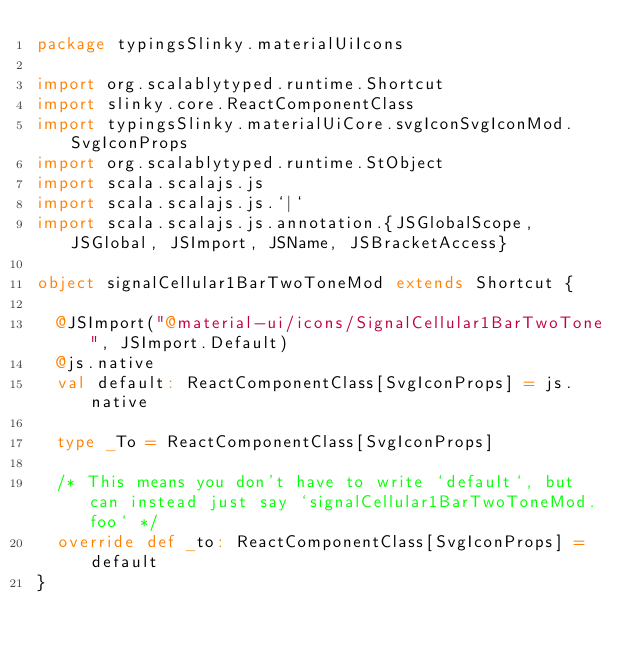Convert code to text. <code><loc_0><loc_0><loc_500><loc_500><_Scala_>package typingsSlinky.materialUiIcons

import org.scalablytyped.runtime.Shortcut
import slinky.core.ReactComponentClass
import typingsSlinky.materialUiCore.svgIconSvgIconMod.SvgIconProps
import org.scalablytyped.runtime.StObject
import scala.scalajs.js
import scala.scalajs.js.`|`
import scala.scalajs.js.annotation.{JSGlobalScope, JSGlobal, JSImport, JSName, JSBracketAccess}

object signalCellular1BarTwoToneMod extends Shortcut {
  
  @JSImport("@material-ui/icons/SignalCellular1BarTwoTone", JSImport.Default)
  @js.native
  val default: ReactComponentClass[SvgIconProps] = js.native
  
  type _To = ReactComponentClass[SvgIconProps]
  
  /* This means you don't have to write `default`, but can instead just say `signalCellular1BarTwoToneMod.foo` */
  override def _to: ReactComponentClass[SvgIconProps] = default
}
</code> 